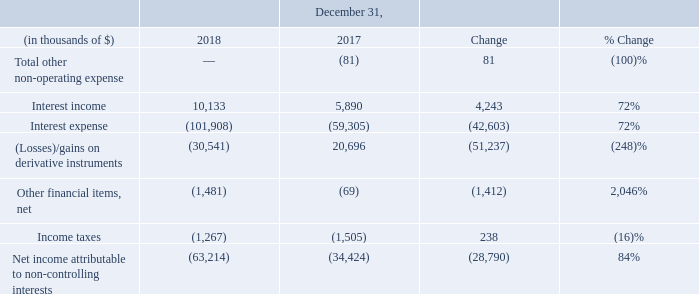Other non-operating results
The following details our other consolidated results for the years ended December 31, 2018 and 2017:
Interest income: Interest income increased by $4.2 million to $10.1 million for the year ended December 31, 2018, compared to $5.9 million for the same period in 2017 due to returns on our fixed deposits that had been made in 2018, and income derived from the lending capital of our lessor VIEs, that we are required to consolidate under U.S. GAAP.
Interest expense: Interest expense increased by $42.6 million to $101.9 million for the year ended December 31, 2018 compared to $59.3 million for the same period in 2017. In addition to higher LIBOR rates, this was primarily due to:
• $22.7 million increase in interest expense arising on the loan facilities of our consolidated lessor VIEs (refer to note 5 "Variable Interest Entities ("VIE")" of our consolidated financial statements included herein), in particular on the Hilli post-delivery sale and leaseback arrangement entered into during June 2018;
• $21.7 million lower capitalized interest on borrowing costs in relation to our investment in the Hilli FLNG conversion prior to acceptance of the vessel;
• $7.0 million increase in amortization of deferred financing costs in relation to the Hilli facility; and
• $1.4 million increase in interest expense in relation to the $402.5 million convertible bond issued in February 2017, resulting in a full year of interest incurred in 2018.
This was partially offset by a decrease of:
• $5.9 million in interest expense relating to the Hilli disposal; and
• $5.0 million higher capitalized interest on borrowing costs in relation to our investment in Golar Power.
(Losses)/gains on derivative instruments: Losses on derivative instruments increased by $51.2 million to a loss of $30.5 million for the year ended December 31, 2018 compared to a gain of $20.7 million for the same period in 2017. The movement was primarily due to:
Net unrealized and realized gains on interest rate swap agreements: As of December 31, 2018, we have an interest rate swap portfolio with a notional amount of $950 million, none of which are designated as hedges for accounting purposes. Net unrealized gains on the interest rate swaps decreased to a gain of $0.6 million for the year ended December 31, 2018 compared to a gain of $6.6 million for the same period in 2017, due to an improvement in the long-term swap rates, offset by the decreased notional value of the swap portfolio over the period. Realized gains on our interest rate swaps increased to a gain of $8.1 million for the year ended December 31, 2018, compared to a loss of $3.8 million for the same period in 2017. The increase was primarily due to higher LIBOR rates for the year ended December 31, 2018.
Unrealized (losses) gains on Total Return Swap (or equity swap): In December 2014, we established a three month facility for a Stock Indexed Total Return Swap Programme or Equity Swap Line with DNB Bank ASA in connection with a share buyback scheme. The facility has been extended to June 2019. The equity swap derivatives mark-to-market adjustment resulted in a net loss of $30.7 million recognized in the year ended December 31, 2018 compared to a gain of $16.6 million for the same period in 2017. The loss in 2018 is due to the fall in our share price during 2018.
Unrealized mark-to-market losses on Earn-Out Units: This relates to the mark-to-market movement on the Earn-Out Units issuable in connection with the IDR reset transaction in October 2016, which we recognize as a derivative asset in our consolidated financial statements. The decrease in Golar Partners' quarterly distribution to $0.4042 per common unit on October 24, 2018 resulted in the contingent Earn-Out Units arising out of the IDR reset transaction in October 2016 not crystallizing and, accordingly, we recognized a mark-to-market loss of $7.4 million for the year ended December 31, 2018, effectively reducing the derivative asset to $nil at December 31, 2018, compared to a gain of $0.4 million for the same period in 2017.
Net income attributable to non-controlling interests: The net income attributable to non-controlling interests comprises of (i) $19.7 million and $1.5 million in relation to the non-controlling shareholders who hold interests in Hilli LLC and Hilli Corp (prior to the incorporation of Hilli LLC) for the year ended December 31, 2018 and 2017, respectively, and (ii) $43.5 million and $32.9 million in relation to the equity interests in our lessor VIEs for the year ended December 31, 2018 and 2017, respectively.
In which years was the consolidated results recorded for? 2017, 2018. What was the net income attributable to non-controlling shareholders who hold interests in Hilli LLC and Hilli Corp in 2017? $1.5 million. What accounted for the increase in interest income? Due to returns on our fixed deposits that had been made in 2018, and income derived from the lending capital of our lessor vies, that we are required to consolidate under u.s. gaap. Which year has a higher income tax? (1,505) > (1,267)
Answer: 2017. What was the change in net unrealized gains on the interest rate swaps between 2017 and 2018?
Answer scale should be: million. $0.6 million - $6.6 million 
Answer: -6. What was the percentage change net income attributable to non-controlling shareholders who hold interests in Hilli LLC and Hilli Corp between 2017 and 2018?
Answer scale should be: percent. (19.7 - 1.5)/1.5 
Answer: 1213.33. 